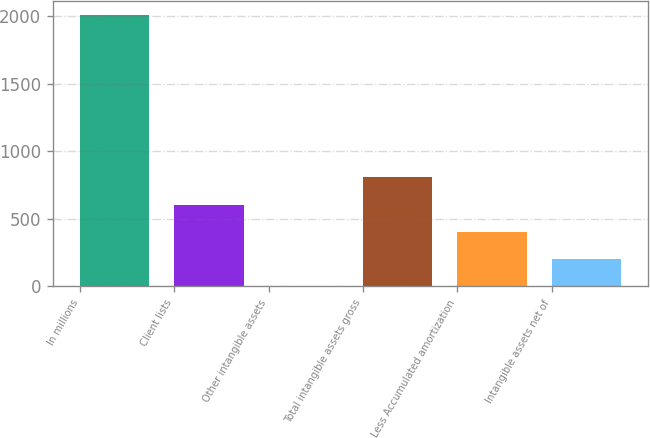Convert chart. <chart><loc_0><loc_0><loc_500><loc_500><bar_chart><fcel>In millions<fcel>Client lists<fcel>Other intangible assets<fcel>Total intangible assets gross<fcel>Less Accumulated amortization<fcel>Intangible assets net of<nl><fcel>2014<fcel>606.02<fcel>2.6<fcel>807.16<fcel>404.88<fcel>203.74<nl></chart> 